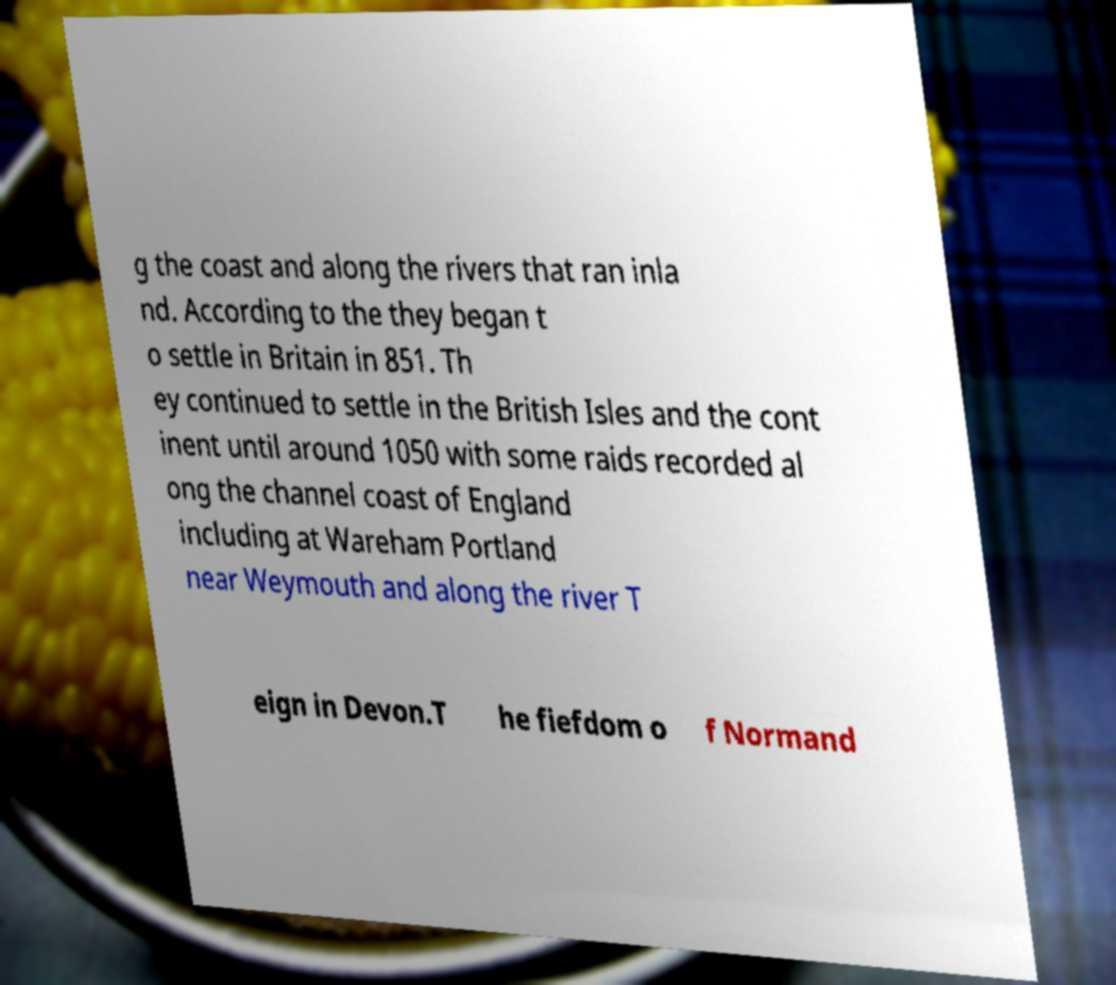Can you accurately transcribe the text from the provided image for me? g the coast and along the rivers that ran inla nd. According to the they began t o settle in Britain in 851. Th ey continued to settle in the British Isles and the cont inent until around 1050 with some raids recorded al ong the channel coast of England including at Wareham Portland near Weymouth and along the river T eign in Devon.T he fiefdom o f Normand 